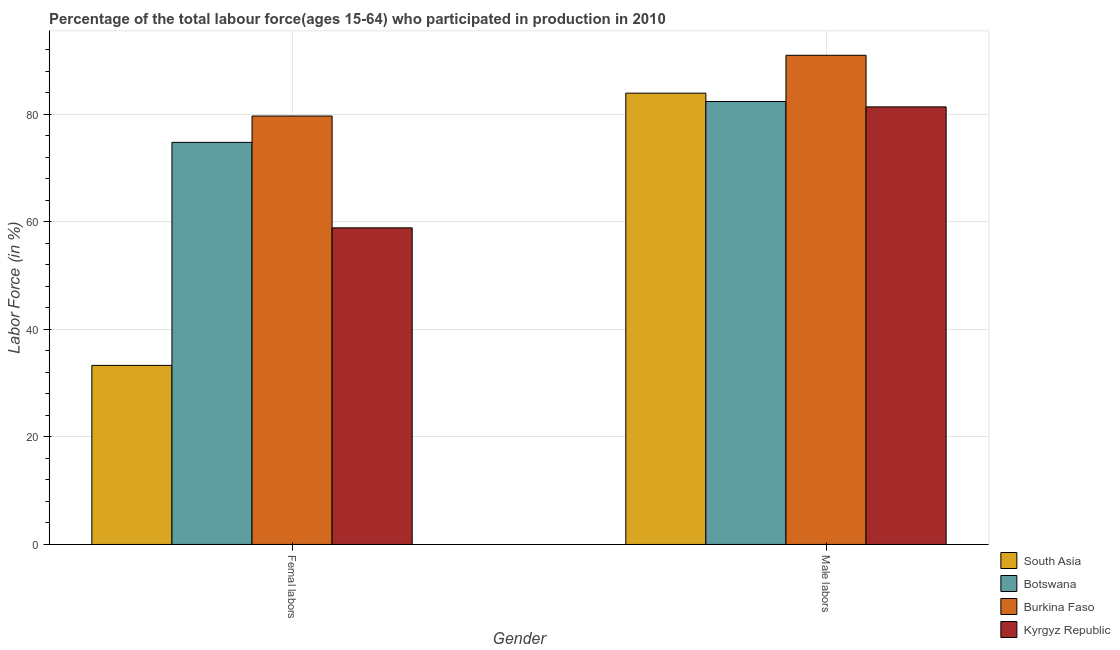Are the number of bars on each tick of the X-axis equal?
Give a very brief answer. Yes. How many bars are there on the 1st tick from the right?
Provide a succinct answer. 4. What is the label of the 1st group of bars from the left?
Keep it short and to the point. Femal labors. What is the percentage of female labor force in Burkina Faso?
Offer a very short reply. 79.7. Across all countries, what is the maximum percentage of male labour force?
Provide a short and direct response. 91. Across all countries, what is the minimum percentage of female labor force?
Provide a short and direct response. 33.31. In which country was the percentage of male labour force maximum?
Make the answer very short. Burkina Faso. In which country was the percentage of male labour force minimum?
Offer a terse response. Kyrgyz Republic. What is the total percentage of male labour force in the graph?
Make the answer very short. 338.75. What is the difference between the percentage of female labor force in Kyrgyz Republic and that in Burkina Faso?
Give a very brief answer. -20.8. What is the difference between the percentage of female labor force in Botswana and the percentage of male labour force in Kyrgyz Republic?
Ensure brevity in your answer.  -6.6. What is the average percentage of male labour force per country?
Provide a succinct answer. 84.69. What is the difference between the percentage of female labor force and percentage of male labour force in Botswana?
Offer a very short reply. -7.6. In how many countries, is the percentage of male labour force greater than 72 %?
Offer a terse response. 4. What is the ratio of the percentage of male labour force in Botswana to that in Kyrgyz Republic?
Give a very brief answer. 1.01. What does the 4th bar from the left in Male labors represents?
Keep it short and to the point. Kyrgyz Republic. How many bars are there?
Your response must be concise. 8. How many countries are there in the graph?
Make the answer very short. 4. Does the graph contain grids?
Your response must be concise. Yes. How many legend labels are there?
Provide a succinct answer. 4. How are the legend labels stacked?
Give a very brief answer. Vertical. What is the title of the graph?
Give a very brief answer. Percentage of the total labour force(ages 15-64) who participated in production in 2010. What is the label or title of the Y-axis?
Make the answer very short. Labor Force (in %). What is the Labor Force (in %) in South Asia in Femal labors?
Ensure brevity in your answer.  33.31. What is the Labor Force (in %) in Botswana in Femal labors?
Give a very brief answer. 74.8. What is the Labor Force (in %) of Burkina Faso in Femal labors?
Ensure brevity in your answer.  79.7. What is the Labor Force (in %) in Kyrgyz Republic in Femal labors?
Keep it short and to the point. 58.9. What is the Labor Force (in %) of South Asia in Male labors?
Make the answer very short. 83.95. What is the Labor Force (in %) in Botswana in Male labors?
Your answer should be very brief. 82.4. What is the Labor Force (in %) in Burkina Faso in Male labors?
Offer a very short reply. 91. What is the Labor Force (in %) in Kyrgyz Republic in Male labors?
Your answer should be very brief. 81.4. Across all Gender, what is the maximum Labor Force (in %) in South Asia?
Give a very brief answer. 83.95. Across all Gender, what is the maximum Labor Force (in %) in Botswana?
Keep it short and to the point. 82.4. Across all Gender, what is the maximum Labor Force (in %) in Burkina Faso?
Your answer should be very brief. 91. Across all Gender, what is the maximum Labor Force (in %) in Kyrgyz Republic?
Your answer should be very brief. 81.4. Across all Gender, what is the minimum Labor Force (in %) of South Asia?
Your answer should be compact. 33.31. Across all Gender, what is the minimum Labor Force (in %) of Botswana?
Ensure brevity in your answer.  74.8. Across all Gender, what is the minimum Labor Force (in %) in Burkina Faso?
Your response must be concise. 79.7. Across all Gender, what is the minimum Labor Force (in %) in Kyrgyz Republic?
Offer a very short reply. 58.9. What is the total Labor Force (in %) in South Asia in the graph?
Provide a short and direct response. 117.26. What is the total Labor Force (in %) of Botswana in the graph?
Keep it short and to the point. 157.2. What is the total Labor Force (in %) in Burkina Faso in the graph?
Provide a succinct answer. 170.7. What is the total Labor Force (in %) of Kyrgyz Republic in the graph?
Your answer should be very brief. 140.3. What is the difference between the Labor Force (in %) of South Asia in Femal labors and that in Male labors?
Offer a very short reply. -50.64. What is the difference between the Labor Force (in %) in Botswana in Femal labors and that in Male labors?
Your answer should be very brief. -7.6. What is the difference between the Labor Force (in %) of Kyrgyz Republic in Femal labors and that in Male labors?
Provide a succinct answer. -22.5. What is the difference between the Labor Force (in %) of South Asia in Femal labors and the Labor Force (in %) of Botswana in Male labors?
Your answer should be very brief. -49.09. What is the difference between the Labor Force (in %) of South Asia in Femal labors and the Labor Force (in %) of Burkina Faso in Male labors?
Your response must be concise. -57.69. What is the difference between the Labor Force (in %) of South Asia in Femal labors and the Labor Force (in %) of Kyrgyz Republic in Male labors?
Provide a short and direct response. -48.09. What is the difference between the Labor Force (in %) in Botswana in Femal labors and the Labor Force (in %) in Burkina Faso in Male labors?
Give a very brief answer. -16.2. What is the difference between the Labor Force (in %) in Botswana in Femal labors and the Labor Force (in %) in Kyrgyz Republic in Male labors?
Offer a very short reply. -6.6. What is the average Labor Force (in %) in South Asia per Gender?
Ensure brevity in your answer.  58.63. What is the average Labor Force (in %) of Botswana per Gender?
Offer a terse response. 78.6. What is the average Labor Force (in %) of Burkina Faso per Gender?
Your response must be concise. 85.35. What is the average Labor Force (in %) in Kyrgyz Republic per Gender?
Give a very brief answer. 70.15. What is the difference between the Labor Force (in %) of South Asia and Labor Force (in %) of Botswana in Femal labors?
Keep it short and to the point. -41.49. What is the difference between the Labor Force (in %) of South Asia and Labor Force (in %) of Burkina Faso in Femal labors?
Offer a terse response. -46.39. What is the difference between the Labor Force (in %) in South Asia and Labor Force (in %) in Kyrgyz Republic in Femal labors?
Your response must be concise. -25.59. What is the difference between the Labor Force (in %) in Burkina Faso and Labor Force (in %) in Kyrgyz Republic in Femal labors?
Offer a terse response. 20.8. What is the difference between the Labor Force (in %) in South Asia and Labor Force (in %) in Botswana in Male labors?
Offer a terse response. 1.55. What is the difference between the Labor Force (in %) of South Asia and Labor Force (in %) of Burkina Faso in Male labors?
Your answer should be compact. -7.05. What is the difference between the Labor Force (in %) of South Asia and Labor Force (in %) of Kyrgyz Republic in Male labors?
Ensure brevity in your answer.  2.55. What is the difference between the Labor Force (in %) in Burkina Faso and Labor Force (in %) in Kyrgyz Republic in Male labors?
Your answer should be very brief. 9.6. What is the ratio of the Labor Force (in %) in South Asia in Femal labors to that in Male labors?
Keep it short and to the point. 0.4. What is the ratio of the Labor Force (in %) of Botswana in Femal labors to that in Male labors?
Provide a short and direct response. 0.91. What is the ratio of the Labor Force (in %) in Burkina Faso in Femal labors to that in Male labors?
Make the answer very short. 0.88. What is the ratio of the Labor Force (in %) in Kyrgyz Republic in Femal labors to that in Male labors?
Keep it short and to the point. 0.72. What is the difference between the highest and the second highest Labor Force (in %) of South Asia?
Give a very brief answer. 50.64. What is the difference between the highest and the second highest Labor Force (in %) of Kyrgyz Republic?
Your response must be concise. 22.5. What is the difference between the highest and the lowest Labor Force (in %) of South Asia?
Provide a succinct answer. 50.64. What is the difference between the highest and the lowest Labor Force (in %) of Burkina Faso?
Give a very brief answer. 11.3. 